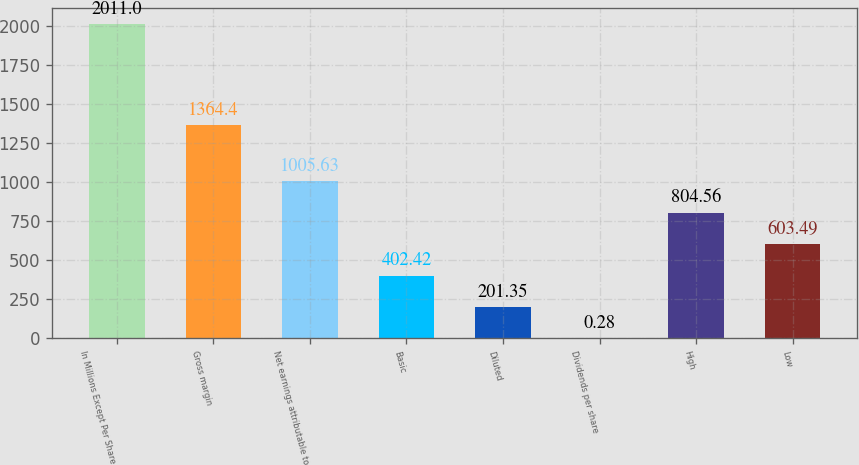Convert chart. <chart><loc_0><loc_0><loc_500><loc_500><bar_chart><fcel>In Millions Except Per Share<fcel>Gross margin<fcel>Net earnings attributable to<fcel>Basic<fcel>Diluted<fcel>Dividends per share<fcel>High<fcel>Low<nl><fcel>2011<fcel>1364.4<fcel>1005.63<fcel>402.42<fcel>201.35<fcel>0.28<fcel>804.56<fcel>603.49<nl></chart> 